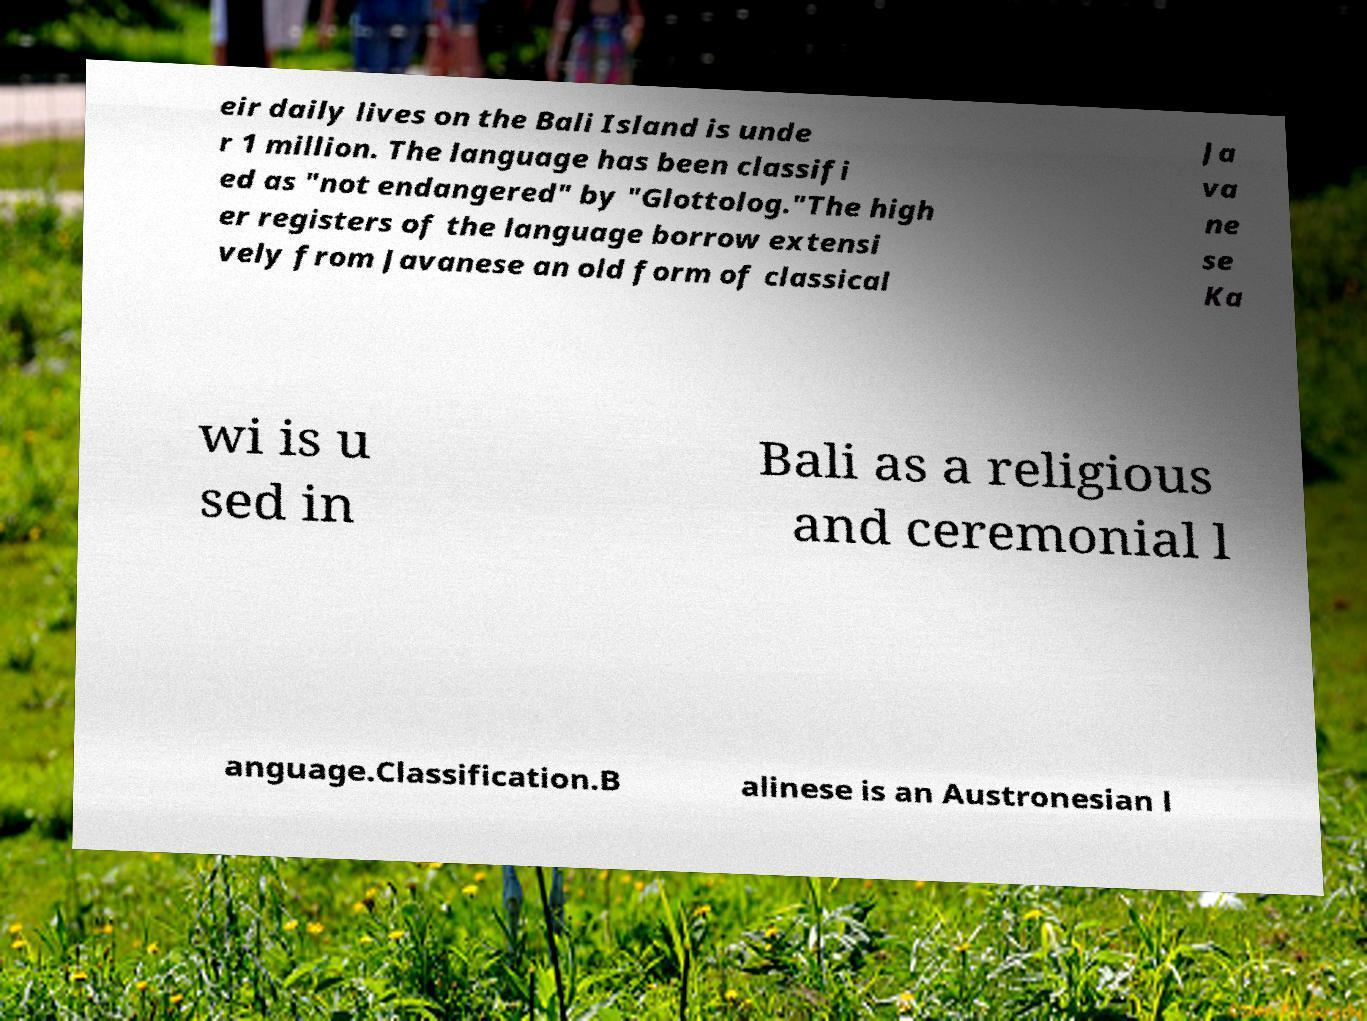Please identify and transcribe the text found in this image. eir daily lives on the Bali Island is unde r 1 million. The language has been classifi ed as "not endangered" by "Glottolog."The high er registers of the language borrow extensi vely from Javanese an old form of classical Ja va ne se Ka wi is u sed in Bali as a religious and ceremonial l anguage.Classification.B alinese is an Austronesian l 